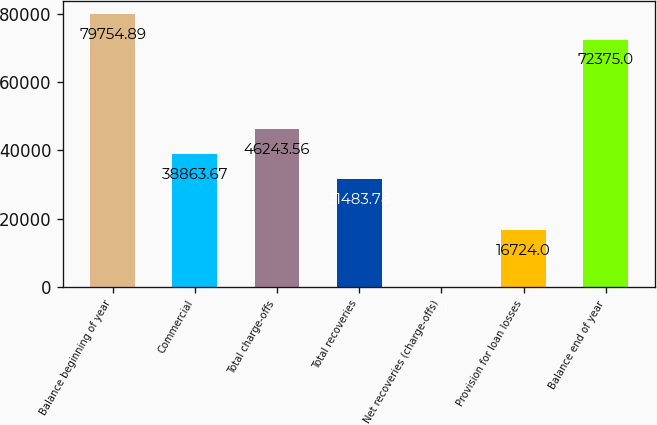Convert chart to OTSL. <chart><loc_0><loc_0><loc_500><loc_500><bar_chart><fcel>Balance beginning of year<fcel>Commercial<fcel>Total charge-offs<fcel>Total recoveries<fcel>Net recoveries (charge-offs)<fcel>Provision for loan losses<fcel>Balance end of year<nl><fcel>79754.9<fcel>38863.7<fcel>46243.6<fcel>31483.8<fcel>1.1<fcel>16724<fcel>72375<nl></chart> 